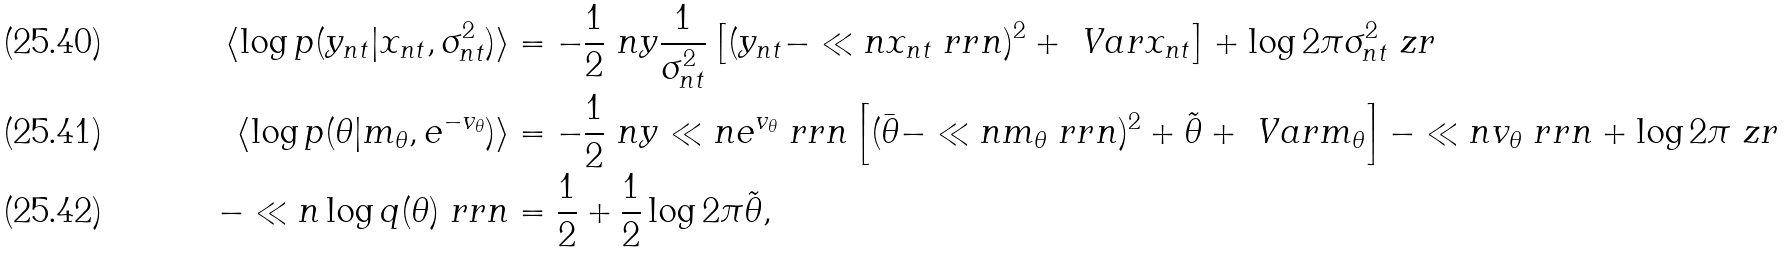<formula> <loc_0><loc_0><loc_500><loc_500>\langle \log p ( y _ { n t } | x _ { n t } , \sigma _ { n t } ^ { 2 } ) \rangle & = - \frac { 1 } { 2 } \ n y \frac { 1 } { \sigma _ { n t } ^ { 2 } } \left [ ( y _ { n t } - \ll n x _ { n t } \ r r n ) ^ { 2 } + \ V a r { x _ { n t } } \right ] + \log 2 \pi \sigma _ { n t } ^ { 2 } \ z r \\ \langle \log p ( \theta | m _ { \theta } , e ^ { - v _ { \theta } } ) \rangle & = - \frac { 1 } { 2 } \ n y \ll n e ^ { v _ { \theta } } \ r r n \left [ ( \bar { \theta } - \ll n m _ { \theta } \ r r n ) ^ { 2 } + \tilde { \theta } + \ V a r { m _ { \theta } } \right ] - \ll n v _ { \theta } \ r r n + \log 2 \pi \ z r \\ - \ll n \log q ( \theta ) \ r r n & = \frac { 1 } { 2 } + \frac { 1 } { 2 } \log 2 \pi \tilde { \theta } ,</formula> 